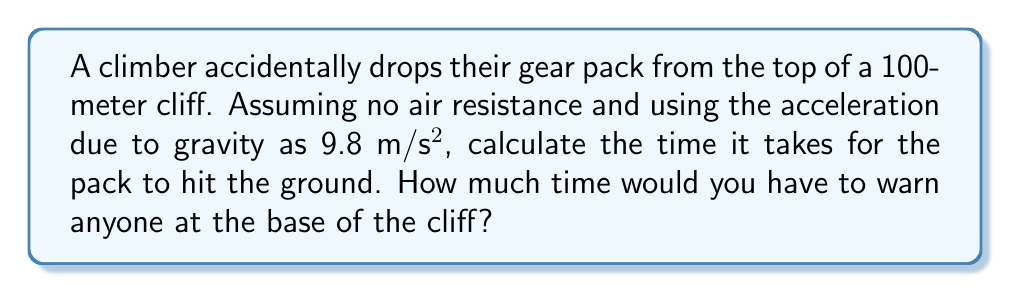Could you help me with this problem? To solve this problem, we'll use the equation for distance traveled by an object under constant acceleration:

$$d = \frac{1}{2}at^2$$

Where:
$d$ = distance traveled (100 m)
$a$ = acceleration due to gravity (9.8 m/s²)
$t$ = time (what we're solving for)

Step 1: Substitute the known values into the equation:
$$100 = \frac{1}{2}(9.8)t^2$$

Step 2: Multiply both sides by 2:
$$200 = 9.8t^2$$

Step 3: Divide both sides by 9.8:
$$\frac{200}{9.8} = t^2$$

Step 4: Take the square root of both sides:
$$t = \sqrt{\frac{200}{9.8}}$$

Step 5: Calculate the result:
$$t \approx 4.52 \text{ seconds}$$

Therefore, you would have approximately 4.52 seconds to warn anyone at the base of the cliff about the falling gear pack.
Answer: $4.52 \text{ seconds}$ 